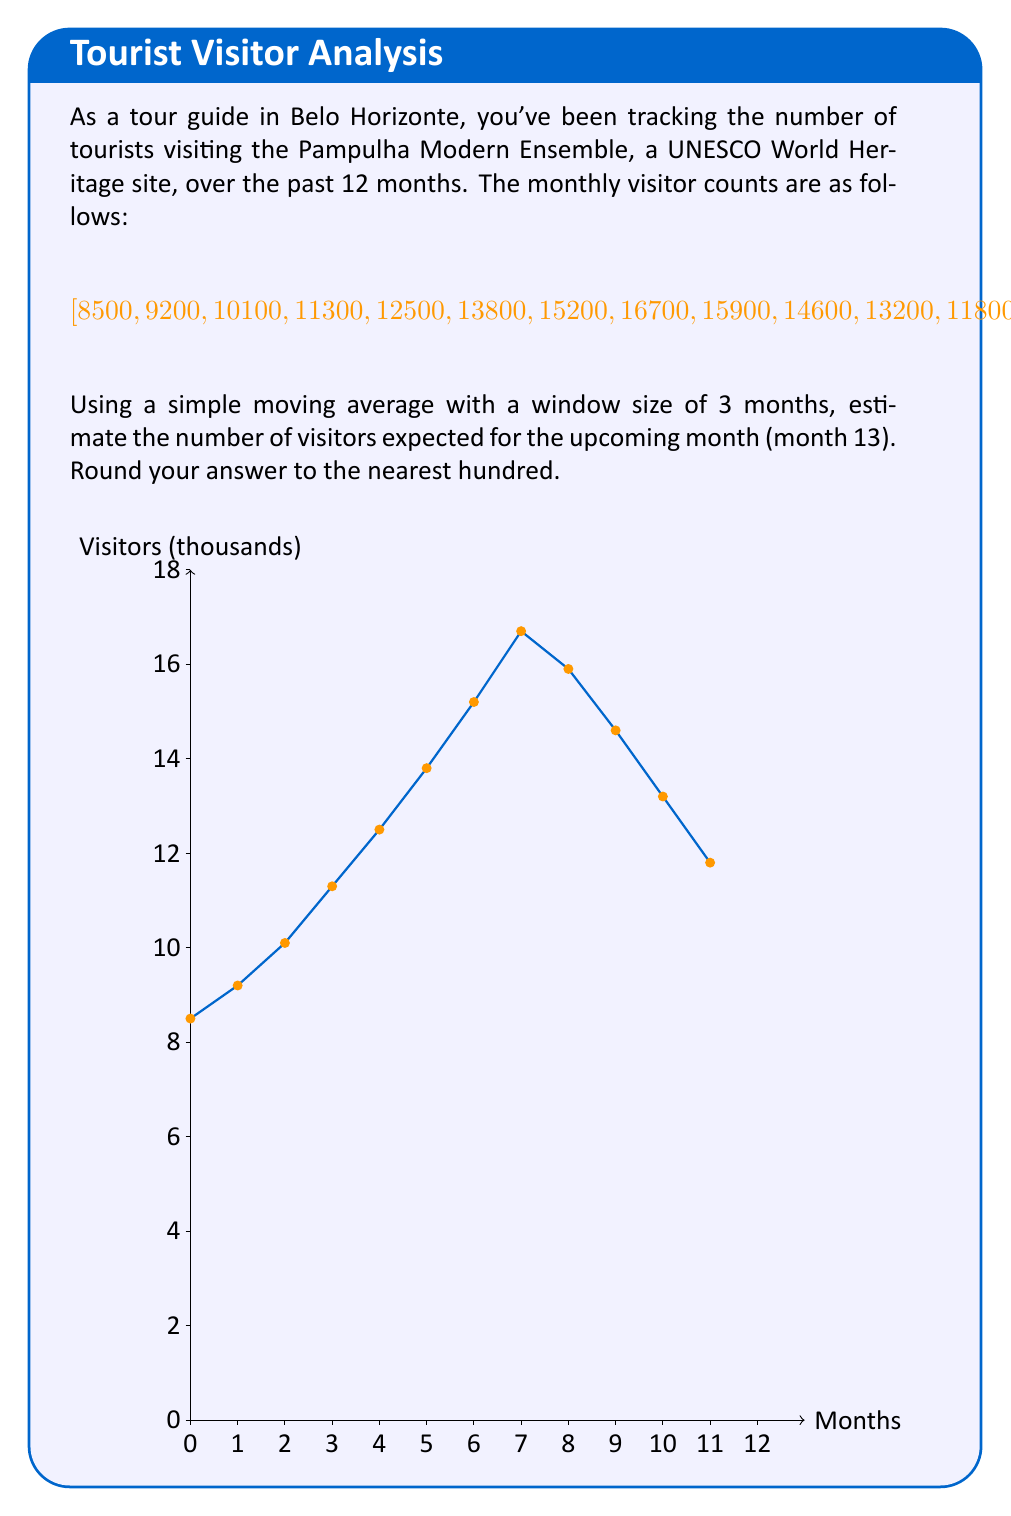Provide a solution to this math problem. To solve this problem, we'll use a simple moving average (SMA) with a window size of 3 months. Here's the step-by-step process:

1) The simple moving average is calculated by taking the average of a fixed number of previous data points. In this case, we'll use the last 3 months.

2) The formula for SMA is:

   $$SMA = \frac{1}{n} \sum_{i=1}^{n} x_i$$

   where $n$ is the window size (3 in this case) and $x_i$ are the data points.

3) We need to calculate the SMA using the last 3 months of data (months 10, 11, and 12):

   $$SMA = \frac{14600 + 13200 + 11800}{3}$$

4) Let's perform the calculation:

   $$SMA = \frac{39600}{3} = 13200$$

5) Therefore, the estimated number of visitors for month 13 is 13,200.

6) Rounding to the nearest hundred gives us 13,200.

This method assumes that the immediate past is the best predictor of the future, which is often a reasonable assumption for short-term forecasts in tourism.
Answer: 13,200 